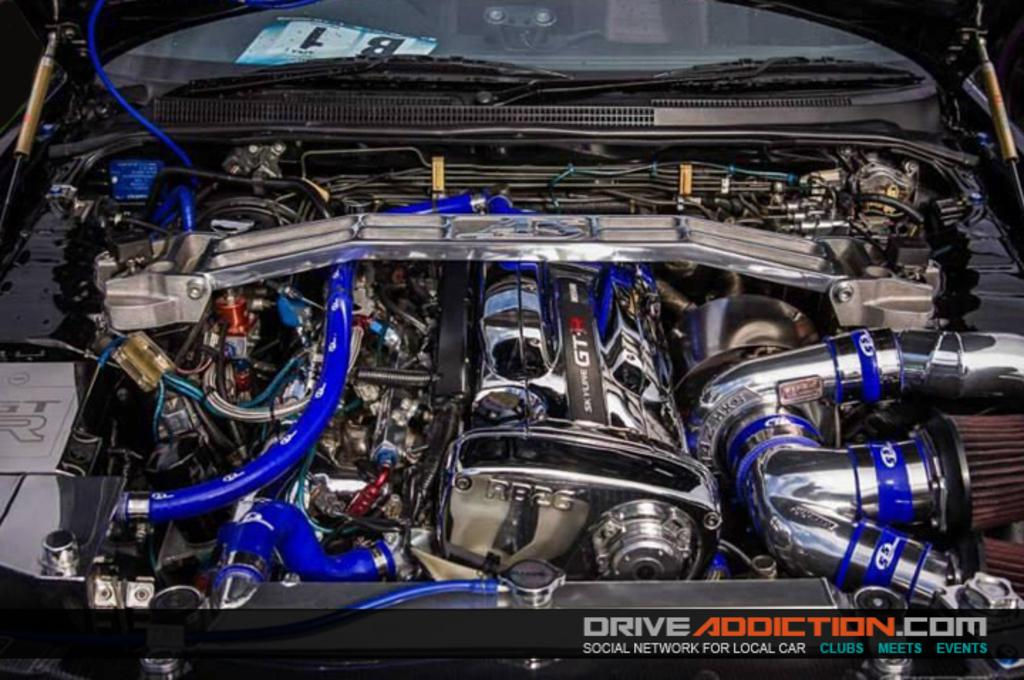What is the position of the bonnet in the image? The bonnet of the car is open in the image. What part of the car can be seen when the bonnet is open? The engine of the car is visible in the image. How many uncles are sitting on the root of the car in the image? There are no uncles or roots present in the image; it features an open bonnet and visible engine. 